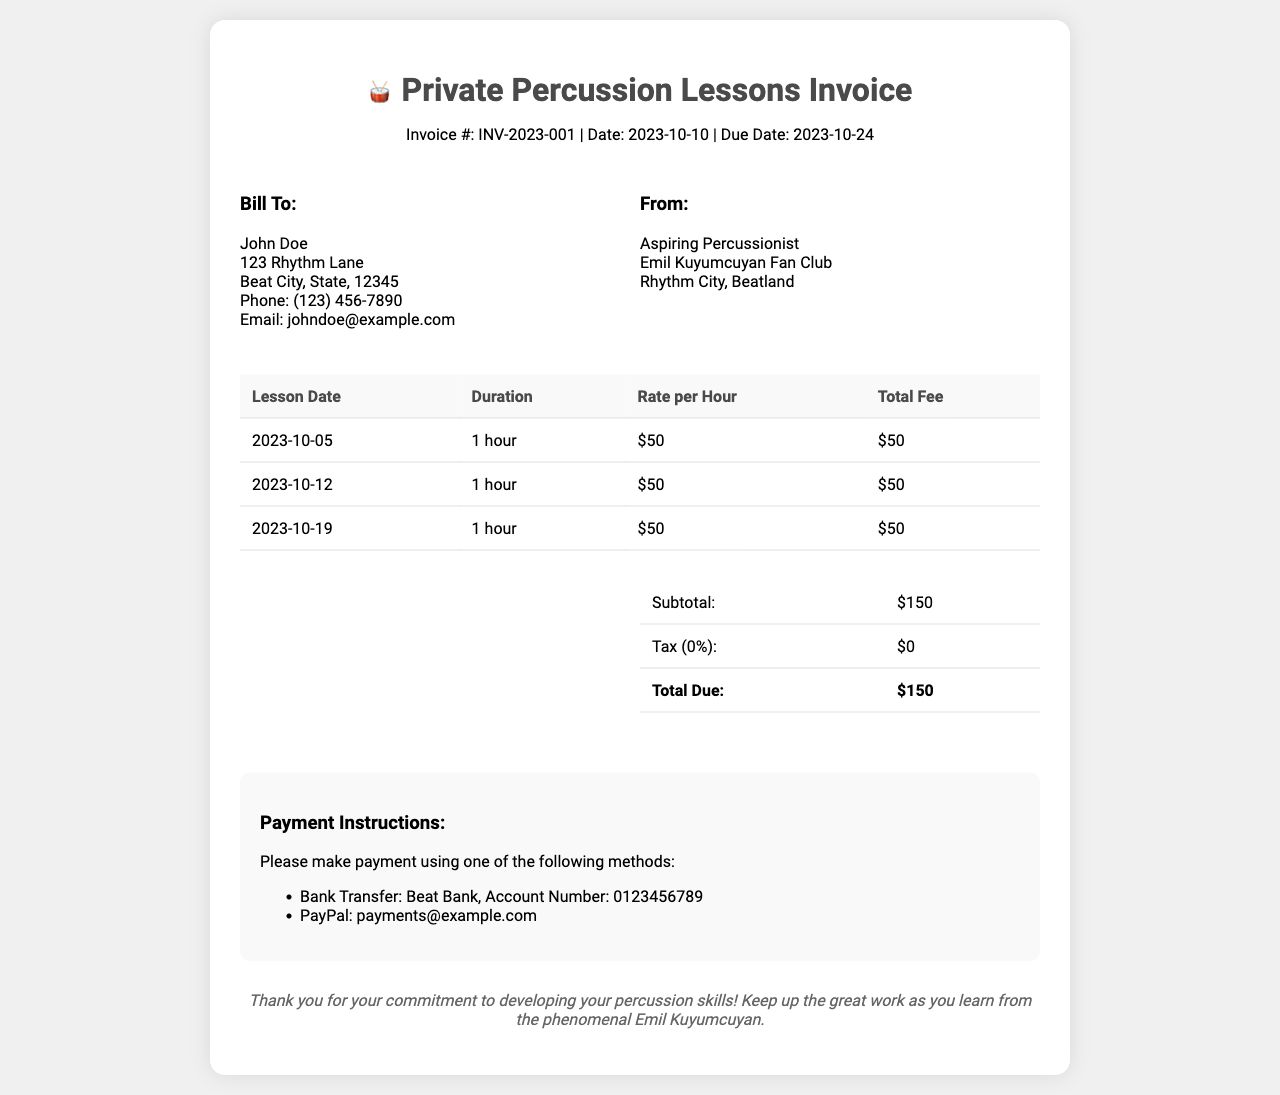What is the invoice number? The invoice number is listed at the top of the document for reference, which is INV-2023-001.
Answer: INV-2023-001 When is the due date? The due date is mentioned in the invoice's header section, which is 2023-10-24.
Answer: 2023-10-24 What is the rate per hour for the lessons? The rate per hour is specified in the table for each lesson, which is $50.
Answer: $50 How many lessons are billed in this invoice? Counting the lessons listed in the table provides the total number of billed lessons, which is three.
Answer: 3 What is the total fee due? The total fee due is calculated from the summary section, which states the total amount is $150.
Answer: $150 What payment methods are mentioned? The payment instructions section lists methods for payment, including Bank Transfer and PayPal.
Answer: Bank Transfer and PayPal What is the subtotal before tax? The subtotal can be found in the summary table, which shows a subtotal of $150.
Answer: $150 What is the tax percentage applied? The tax percentage is indicated in the summary table as 0%.
Answer: 0% 